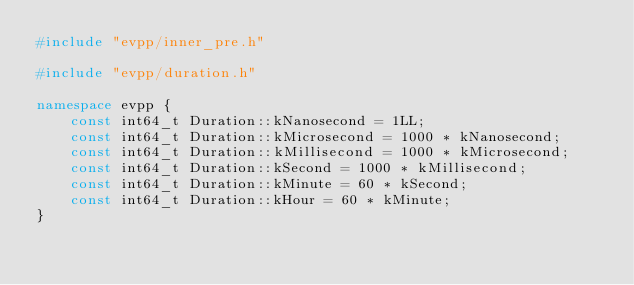<code> <loc_0><loc_0><loc_500><loc_500><_C++_>#include "evpp/inner_pre.h"

#include "evpp/duration.h"

namespace evpp {
    const int64_t Duration::kNanosecond = 1LL;
    const int64_t Duration::kMicrosecond = 1000 * kNanosecond;
    const int64_t Duration::kMillisecond = 1000 * kMicrosecond;
    const int64_t Duration::kSecond = 1000 * kMillisecond;
    const int64_t Duration::kMinute = 60 * kSecond;
    const int64_t Duration::kHour = 60 * kMinute;
}</code> 